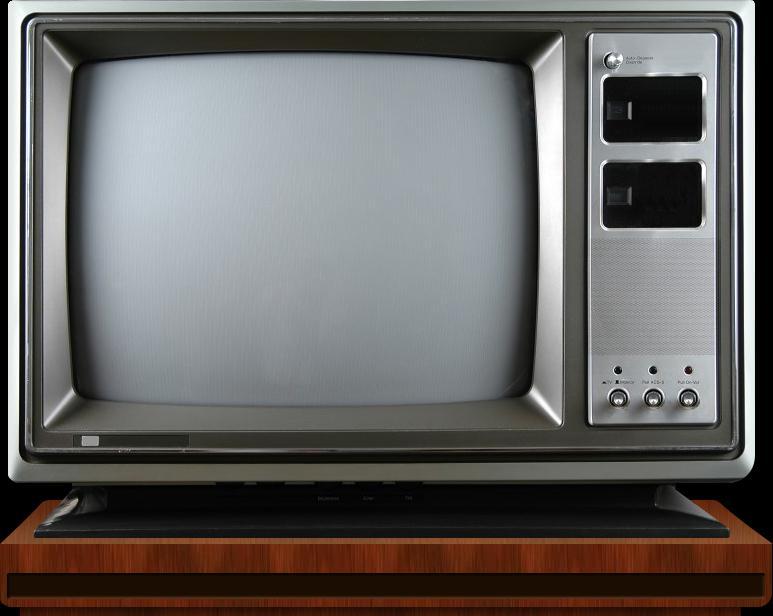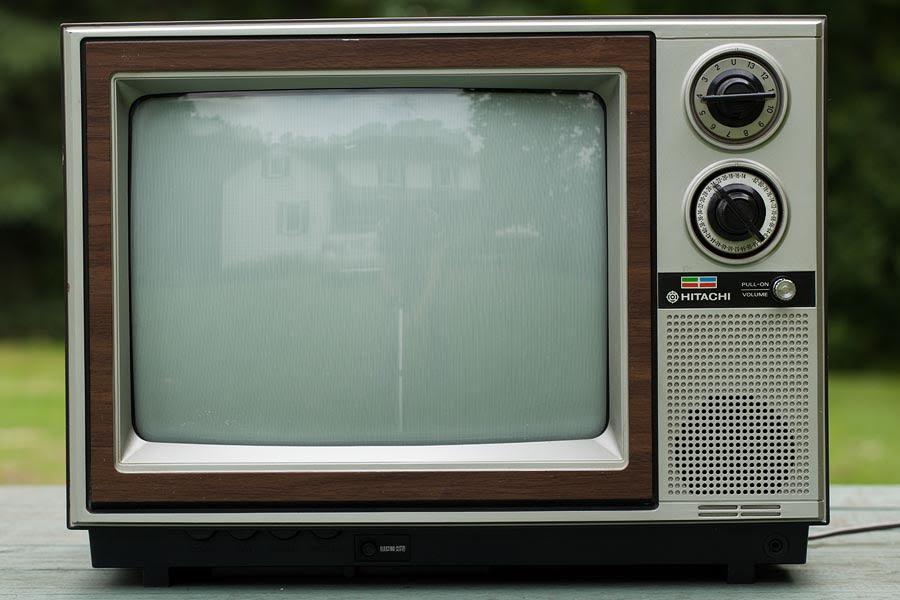The first image is the image on the left, the second image is the image on the right. Analyze the images presented: Is the assertion "One TV has three small knobs in a horizontal row at the bottom right and two black rectangles arranged one over the other on the upper right." valid? Answer yes or no. Yes. The first image is the image on the left, the second image is the image on the right. Given the left and right images, does the statement "One TV is sitting outside with grass and trees in the background." hold true? Answer yes or no. Yes. 